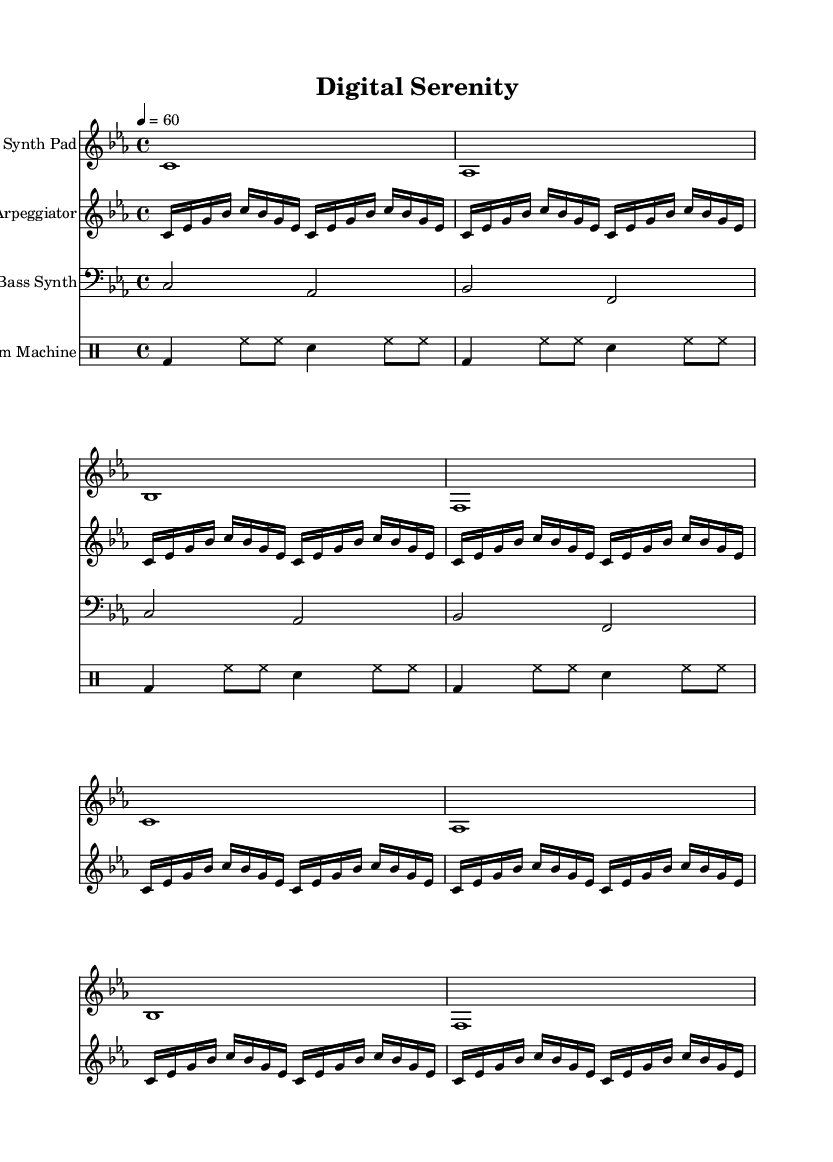What is the key signature of this music? The key signature is indicated at the beginning of the score, showing the key of C minor, which includes three flats (B♭, E♭, A♭).
Answer: C minor What is the time signature? The time signature is noted at the beginning, displayed as 4/4, which indicates four beats per measure with a quarter note receiving one beat.
Answer: 4/4 What is the tempo marking for the piece? The tempo is indicated by the marking "4 = 60", meaning there are 60 beats per minute, and each quarter note receives one beat.
Answer: 60 How many measures are in the synth pad section? The synth pad section consists of two measures as indicated by the repeat notation that unfolds twice.
Answer: 2 What kind of drum patterns are used in the drum machine part? The drum machine part consists of a combination of bass drum (bd), hi-hat (hh), and snare drum (sn), creating a rhythm that is characteristic of electronic music.
Answer: Bass and hi-hat Which instruments are featured in this score? The score features a Synth Pad, Arpeggiator, Bass Synth, and Drum Machine, as seen in the instrument names at the beginning of each staff.
Answer: Synth Pad, Arpeggiator, Bass Synth, Drum Machine How many notes are in the arpeggiator's first phrase? The first phrase of the arpeggiator consists of eight notes, derived from the repeated unfolding of four groups of four sixteenth notes.
Answer: 8 